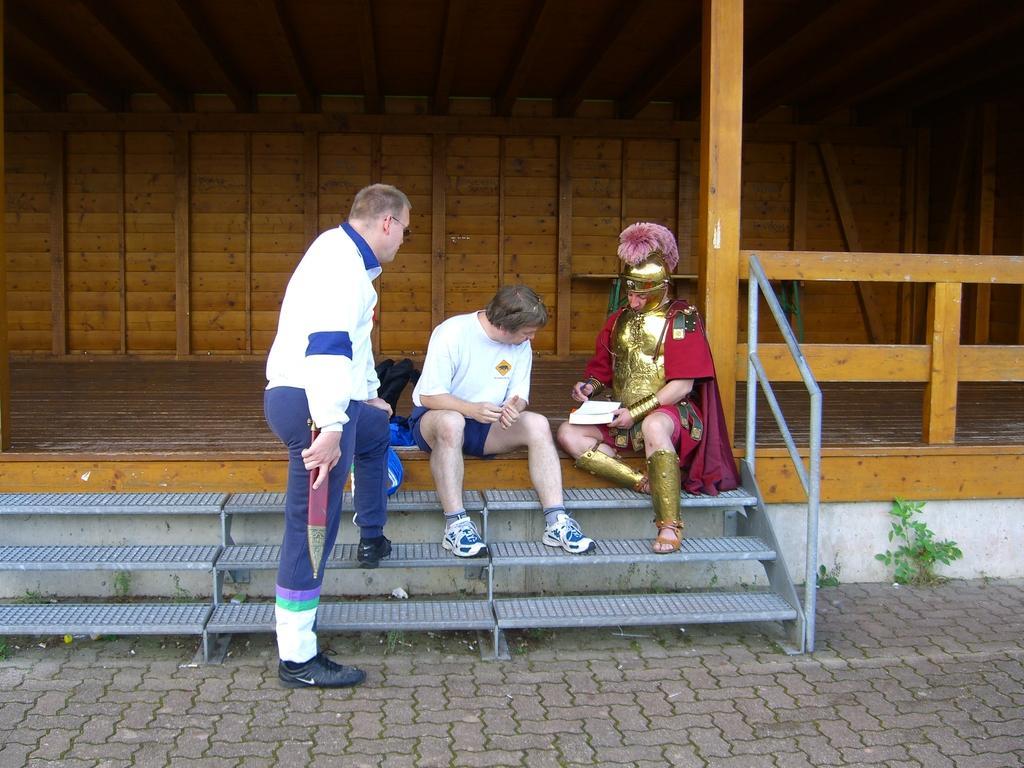Can you describe this image briefly? In the picture I can see three people among them one man is standing and others are sitting. In the background I can see wooden wall. Here I can see steps, fence and plants. 